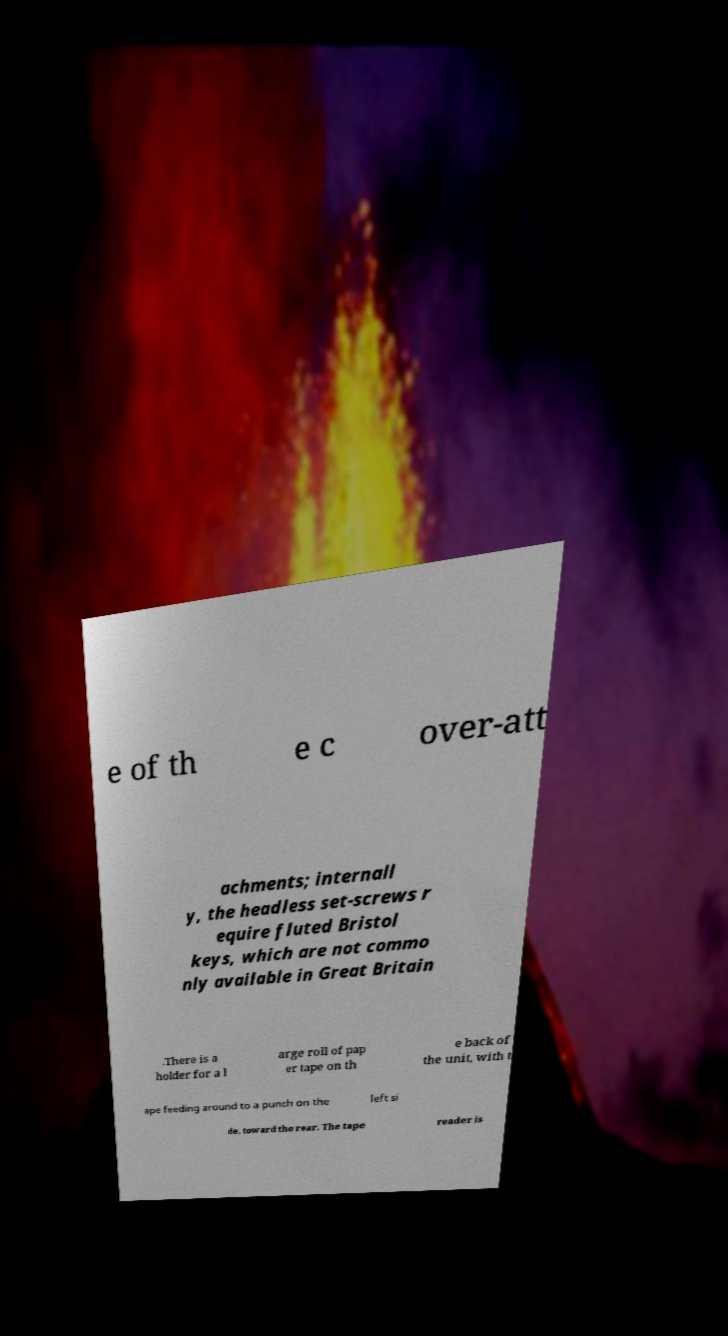Can you read and provide the text displayed in the image?This photo seems to have some interesting text. Can you extract and type it out for me? e of th e c over-att achments; internall y, the headless set-screws r equire fluted Bristol keys, which are not commo nly available in Great Britain .There is a holder for a l arge roll of pap er tape on th e back of the unit, with t ape feeding around to a punch on the left si de, toward the rear. The tape reader is 